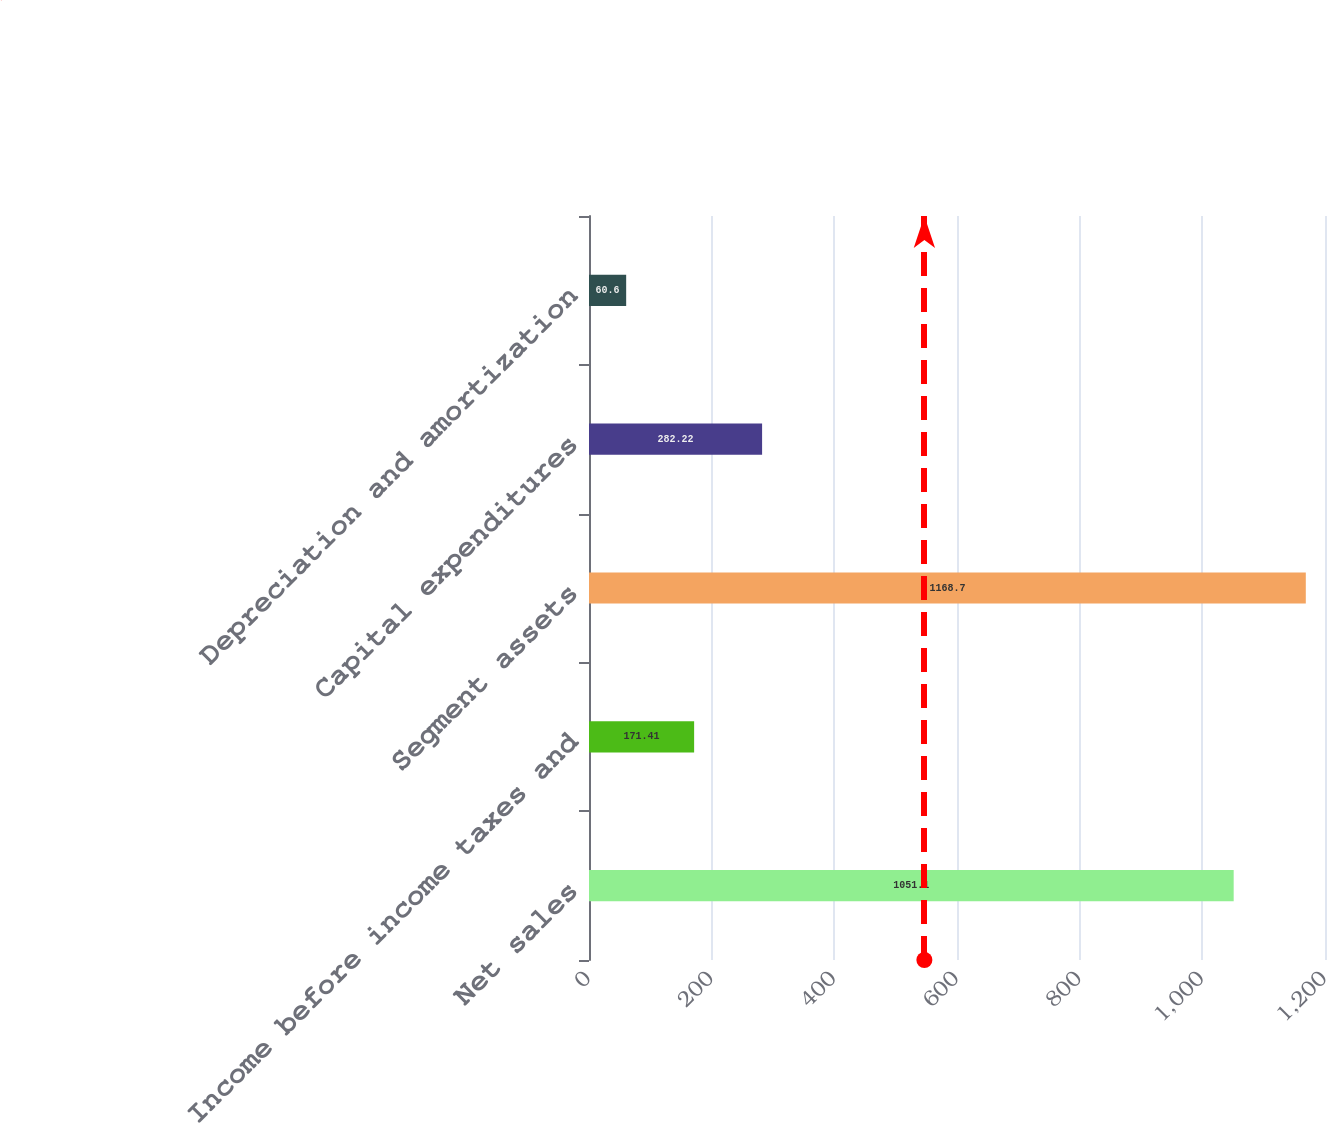Convert chart. <chart><loc_0><loc_0><loc_500><loc_500><bar_chart><fcel>Net sales<fcel>Income before income taxes and<fcel>Segment assets<fcel>Capital expenditures<fcel>Depreciation and amortization<nl><fcel>1051.1<fcel>171.41<fcel>1168.7<fcel>282.22<fcel>60.6<nl></chart> 